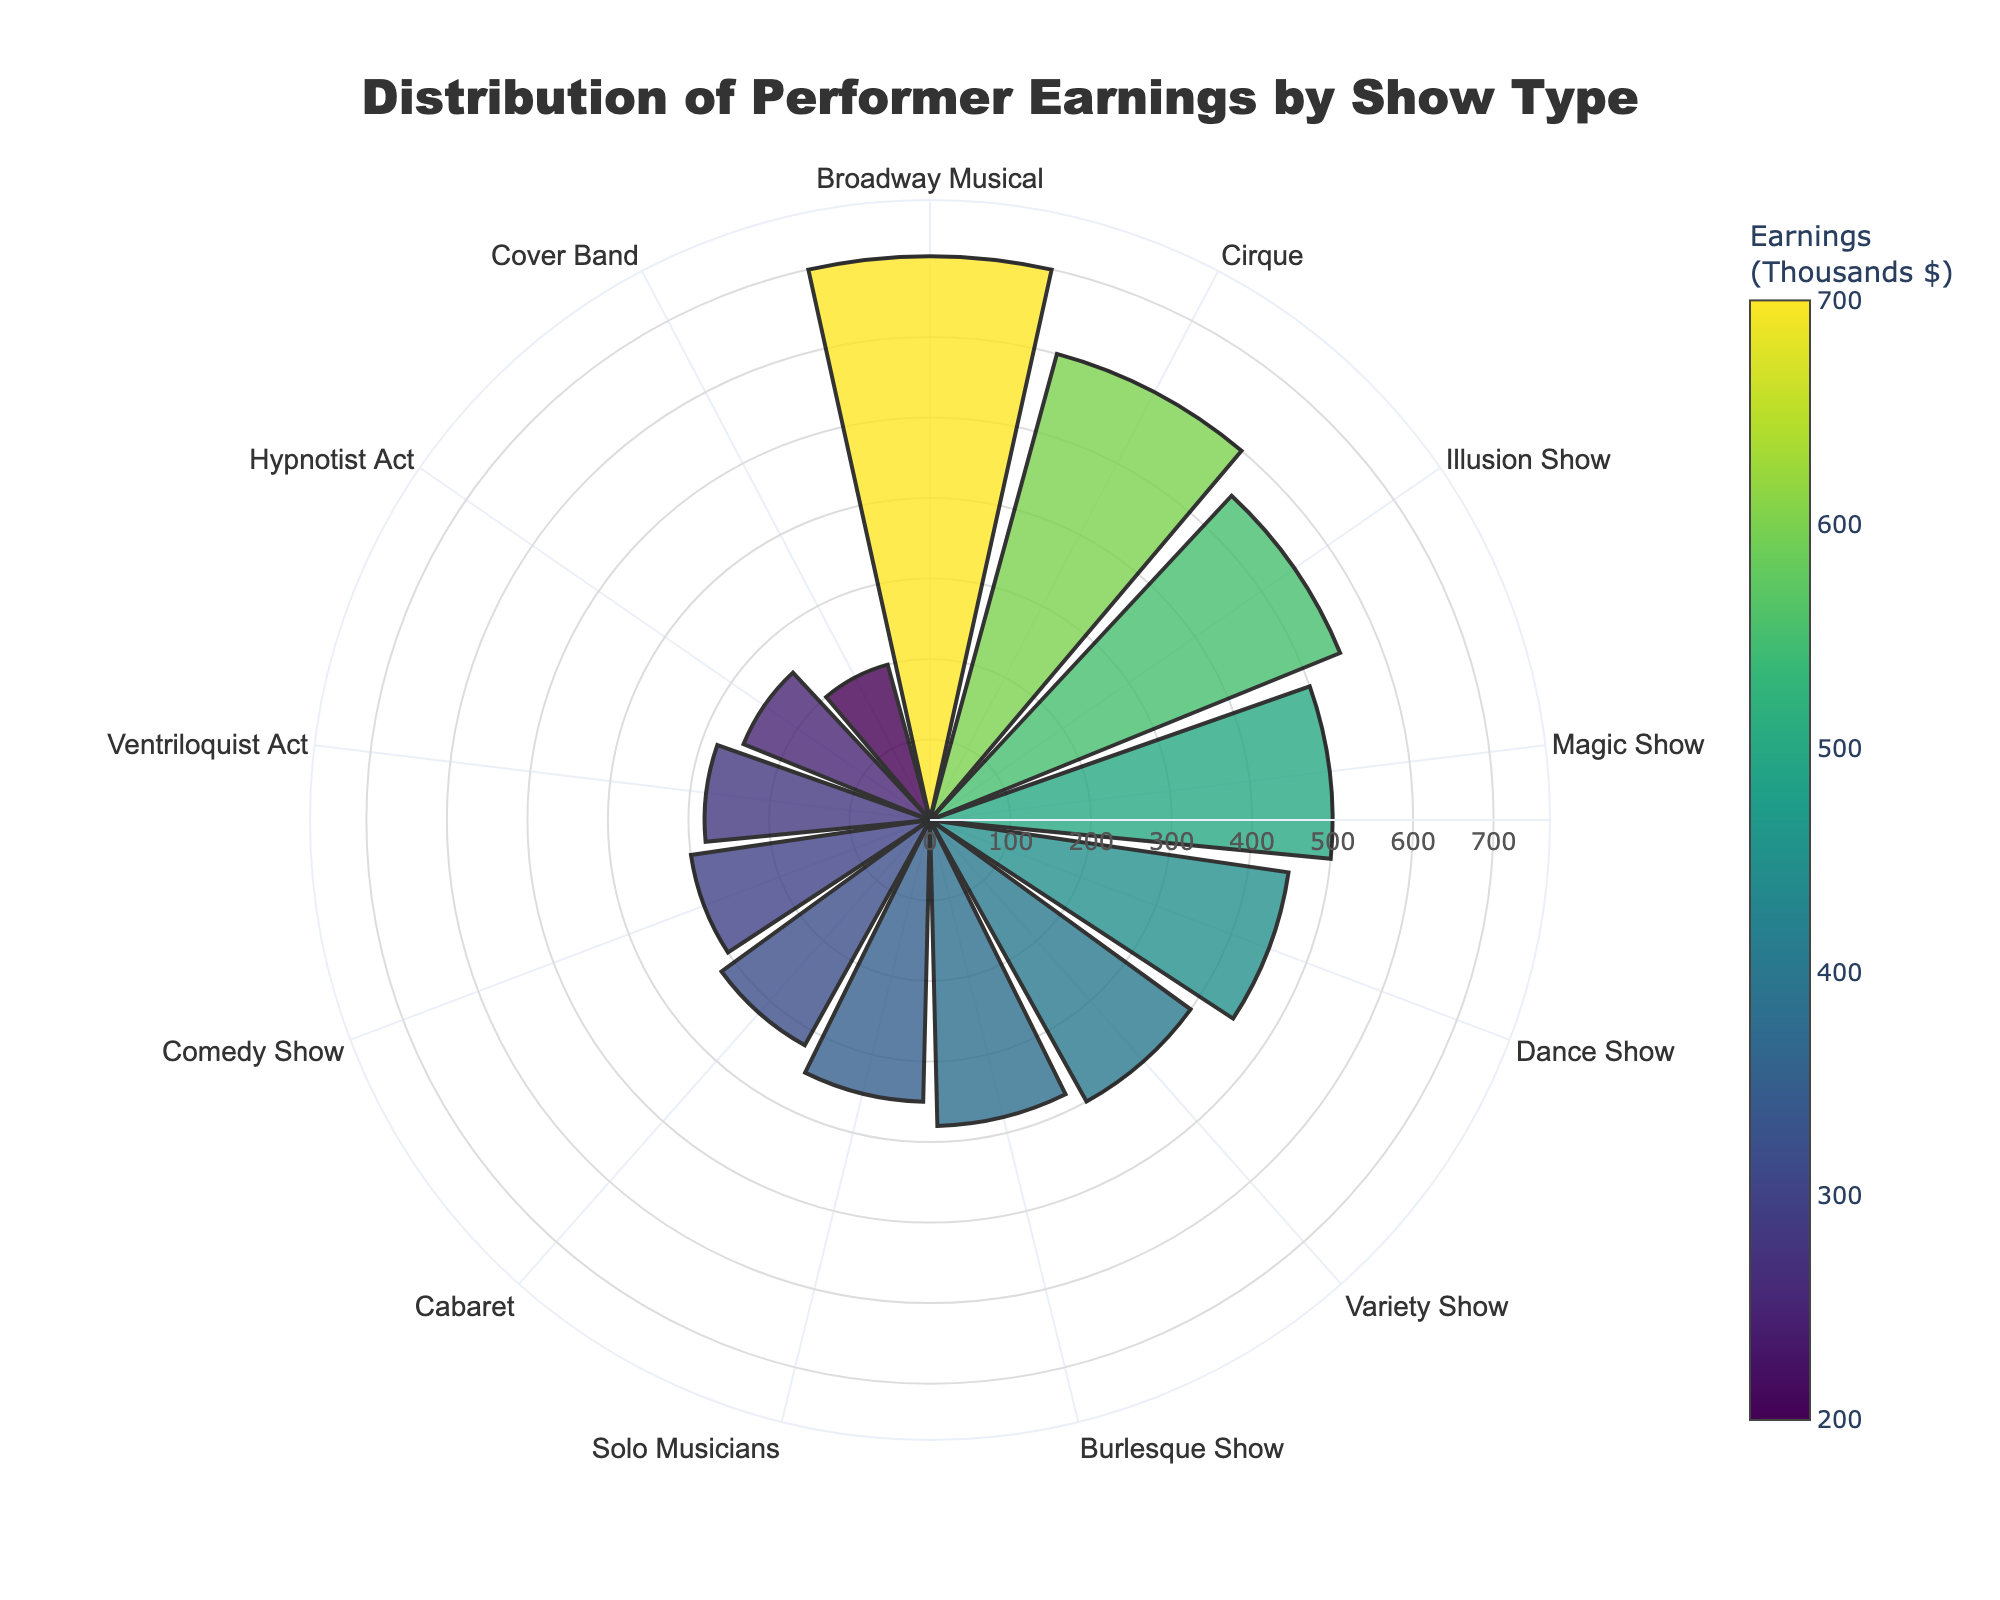What is the title of the chart? The title is typically found at the top of the chart to indicate what the figure represents. In this case, the title is "Distribution of Performer Earnings by Show Type" as specified in the layout update.
Answer: Distribution of Performer Earnings by Show Type What is the show type with the highest earnings? To find the highest earnings, look at the segment with the longest radial length. This corresponds to the Broadway Musical segment with earnings of $700,000.
Answer: Broadway Musical How many show types have earnings above $400,000? Identify the segments above $400,000 earnings. These are Broadway Musical ($700K), Illusion Show ($550K), Cirque ($600K), Magic Show ($500K), and Dance Show ($450K). So, there are 5 such show types.
Answer: 5 What is the average earnings of all show types? Add up all the earnings from the show types and divide by the total number (13). Sum = 500+300+600+200+350+450+400+250+280+380+700+550+320 = 5280. Average = 5280 / 13.
Answer: 406.15 thousands $ How does the earnings of the Comedy Show compare to the Ventriloquist Act? Identify the segments for Comedy Show ($300K) and Ventriloquist Act ($280K) and compare the values. Comedy Show earns slightly more.
Answer: Comedy Show earns more What is the difference in earnings between the highest and lowest earning show types? Find the highest (Broadway Musical, $700K) and lowest (Cover Band, $200K) earning show types and subtract the lowest from the highest. 700 - 200 = 500.
Answer: 500 thousands $ Which show type is represented in the lightest color? Color intensity usually corresponds to the value. The lightest color represents the lowest value which is the Cover Band with $200,000.
Answer: Cover Band How are the earnings of the Illusion Show compared to the Magic Show? To compare, locate both segments. The Illusion Show ($550K) has higher earnings than the Magic Show ($500K).
Answer: Illusion Show earns more What is the median earnings value among all show types? To find the median, list the earnings values in ascending order (200, 250, 280, 300, 320, 350, 380, 400, 450, 500, 550, 600, 700) and find the middle value. The median value is $380,000.
Answer: 380 thousands $ What is the combined earnings of Cirque and Broadway Musical shows? Add the earnings of Cirque ($600K) and Broadway Musical ($700K). 600 + 700 = 1300.
Answer: 1300 thousands $ 